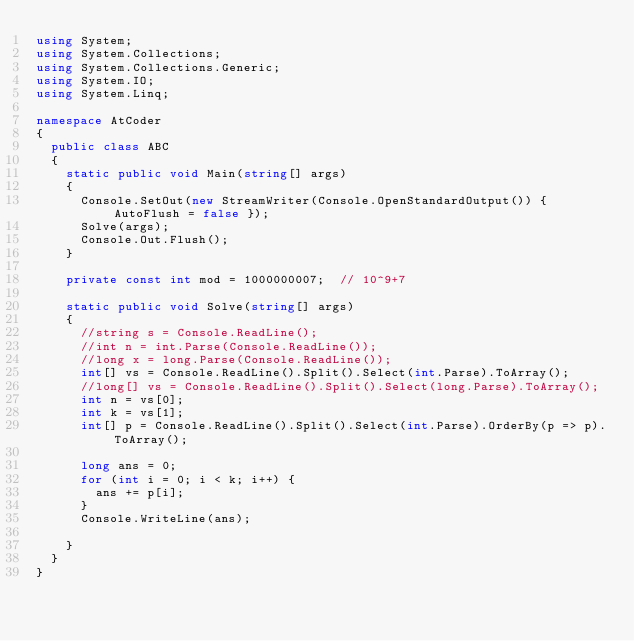Convert code to text. <code><loc_0><loc_0><loc_500><loc_500><_C#_>using System;
using System.Collections;
using System.Collections.Generic;
using System.IO;
using System.Linq;

namespace AtCoder
{
	public class ABC
	{
		static public void Main(string[] args)
		{
			Console.SetOut(new StreamWriter(Console.OpenStandardOutput()) { AutoFlush = false });
			Solve(args);
			Console.Out.Flush();
		}

		private const int mod = 1000000007;  // 10^9+7

		static public void Solve(string[] args)
		{
			//string s = Console.ReadLine();
			//int n = int.Parse(Console.ReadLine());
			//long x = long.Parse(Console.ReadLine());
			int[] vs = Console.ReadLine().Split().Select(int.Parse).ToArray();
			//long[] vs = Console.ReadLine().Split().Select(long.Parse).ToArray();
			int n = vs[0];
			int k = vs[1];
			int[] p = Console.ReadLine().Split().Select(int.Parse).OrderBy(p => p).ToArray();

			long ans = 0;
			for (int i = 0; i < k; i++) {
				ans += p[i];
			}
			Console.WriteLine(ans);

		}
	}
}
</code> 